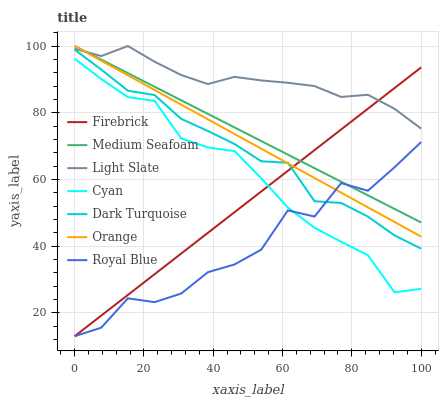Does Dark Turquoise have the minimum area under the curve?
Answer yes or no. No. Does Dark Turquoise have the maximum area under the curve?
Answer yes or no. No. Is Dark Turquoise the smoothest?
Answer yes or no. No. Is Dark Turquoise the roughest?
Answer yes or no. No. Does Dark Turquoise have the lowest value?
Answer yes or no. No. Does Dark Turquoise have the highest value?
Answer yes or no. No. Is Cyan less than Light Slate?
Answer yes or no. Yes. Is Light Slate greater than Dark Turquoise?
Answer yes or no. Yes. Does Cyan intersect Light Slate?
Answer yes or no. No. 